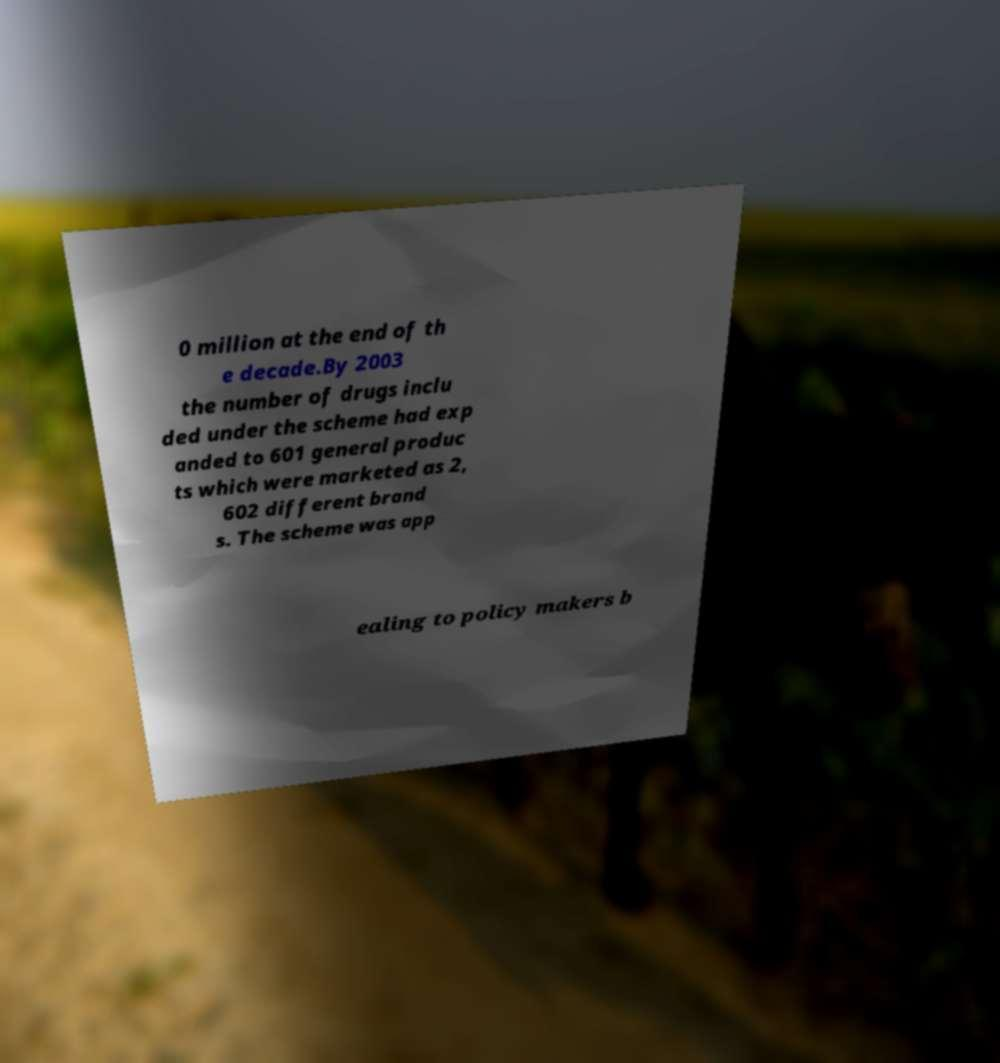Could you assist in decoding the text presented in this image and type it out clearly? 0 million at the end of th e decade.By 2003 the number of drugs inclu ded under the scheme had exp anded to 601 general produc ts which were marketed as 2, 602 different brand s. The scheme was app ealing to policy makers b 